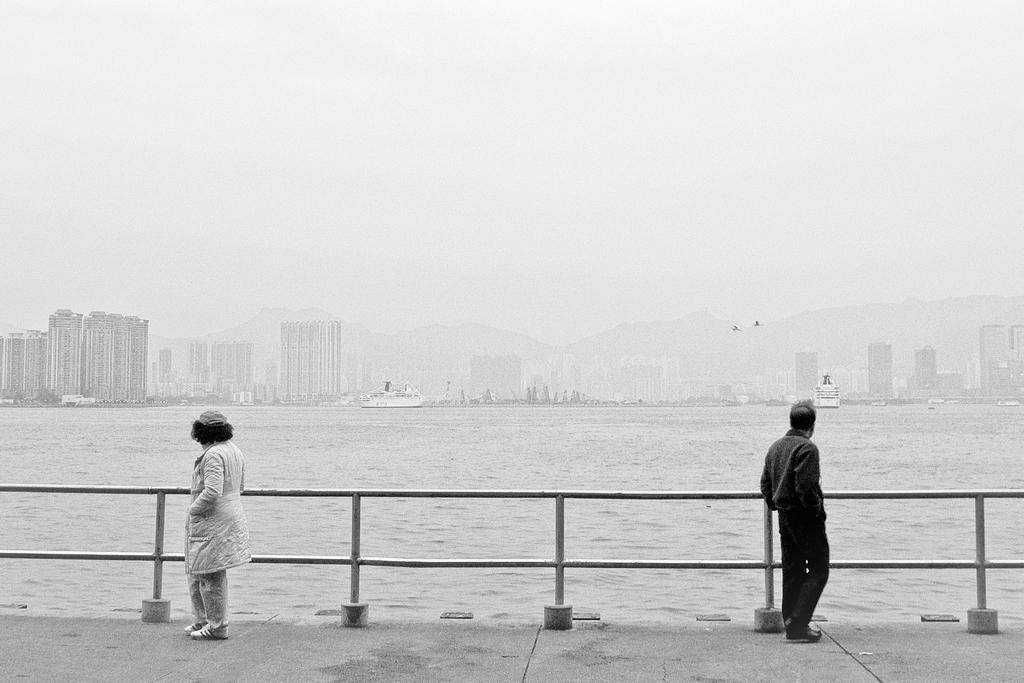In one or two sentences, can you explain what this image depicts? In this image there are two people standing on the pavement. Behind them there is a metal fence. In the center of the image there are ships in the water. In the background of the image there are buildings, mountains and sky. 